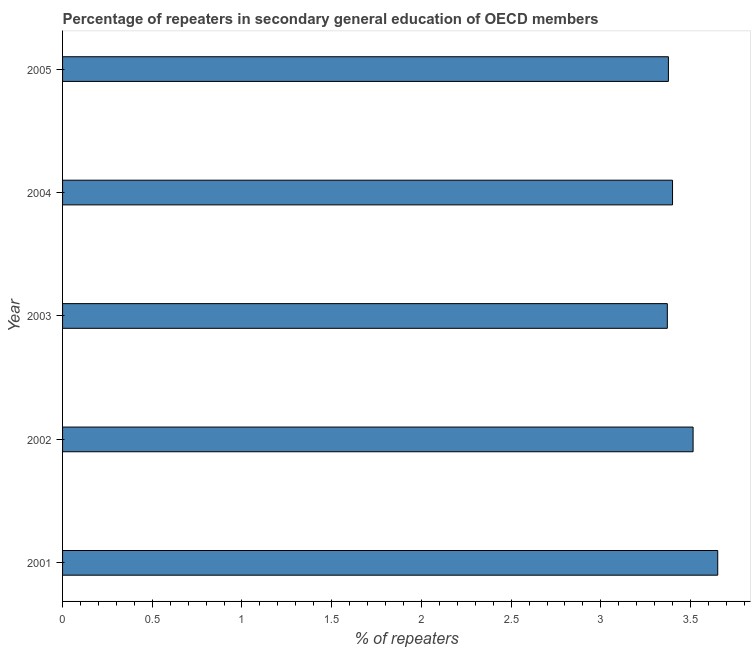Does the graph contain grids?
Give a very brief answer. No. What is the title of the graph?
Keep it short and to the point. Percentage of repeaters in secondary general education of OECD members. What is the label or title of the X-axis?
Offer a terse response. % of repeaters. What is the percentage of repeaters in 2002?
Make the answer very short. 3.51. Across all years, what is the maximum percentage of repeaters?
Offer a terse response. 3.65. Across all years, what is the minimum percentage of repeaters?
Your answer should be very brief. 3.37. In which year was the percentage of repeaters maximum?
Give a very brief answer. 2001. What is the sum of the percentage of repeaters?
Provide a succinct answer. 17.31. What is the difference between the percentage of repeaters in 2001 and 2002?
Your answer should be very brief. 0.14. What is the average percentage of repeaters per year?
Ensure brevity in your answer.  3.46. What is the median percentage of repeaters?
Your answer should be very brief. 3.4. In how many years, is the percentage of repeaters greater than 3.3 %?
Make the answer very short. 5. Do a majority of the years between 2003 and 2001 (inclusive) have percentage of repeaters greater than 1 %?
Offer a very short reply. Yes. What is the ratio of the percentage of repeaters in 2004 to that in 2005?
Your response must be concise. 1.01. What is the difference between the highest and the second highest percentage of repeaters?
Offer a terse response. 0.14. Is the sum of the percentage of repeaters in 2001 and 2004 greater than the maximum percentage of repeaters across all years?
Offer a very short reply. Yes. What is the difference between the highest and the lowest percentage of repeaters?
Ensure brevity in your answer.  0.28. How many years are there in the graph?
Make the answer very short. 5. What is the difference between two consecutive major ticks on the X-axis?
Your response must be concise. 0.5. What is the % of repeaters in 2001?
Your answer should be compact. 3.65. What is the % of repeaters of 2002?
Make the answer very short. 3.51. What is the % of repeaters of 2003?
Your response must be concise. 3.37. What is the % of repeaters of 2004?
Offer a terse response. 3.4. What is the % of repeaters in 2005?
Ensure brevity in your answer.  3.38. What is the difference between the % of repeaters in 2001 and 2002?
Ensure brevity in your answer.  0.14. What is the difference between the % of repeaters in 2001 and 2003?
Ensure brevity in your answer.  0.28. What is the difference between the % of repeaters in 2001 and 2004?
Make the answer very short. 0.25. What is the difference between the % of repeaters in 2001 and 2005?
Make the answer very short. 0.27. What is the difference between the % of repeaters in 2002 and 2003?
Provide a succinct answer. 0.14. What is the difference between the % of repeaters in 2002 and 2004?
Offer a terse response. 0.11. What is the difference between the % of repeaters in 2002 and 2005?
Keep it short and to the point. 0.14. What is the difference between the % of repeaters in 2003 and 2004?
Your answer should be compact. -0.03. What is the difference between the % of repeaters in 2003 and 2005?
Provide a short and direct response. -0.01. What is the difference between the % of repeaters in 2004 and 2005?
Your response must be concise. 0.02. What is the ratio of the % of repeaters in 2001 to that in 2002?
Give a very brief answer. 1.04. What is the ratio of the % of repeaters in 2001 to that in 2003?
Keep it short and to the point. 1.08. What is the ratio of the % of repeaters in 2001 to that in 2004?
Keep it short and to the point. 1.07. What is the ratio of the % of repeaters in 2001 to that in 2005?
Provide a succinct answer. 1.08. What is the ratio of the % of repeaters in 2002 to that in 2003?
Make the answer very short. 1.04. What is the ratio of the % of repeaters in 2002 to that in 2004?
Offer a very short reply. 1.03. What is the ratio of the % of repeaters in 2002 to that in 2005?
Keep it short and to the point. 1.04. What is the ratio of the % of repeaters in 2004 to that in 2005?
Your answer should be very brief. 1.01. 